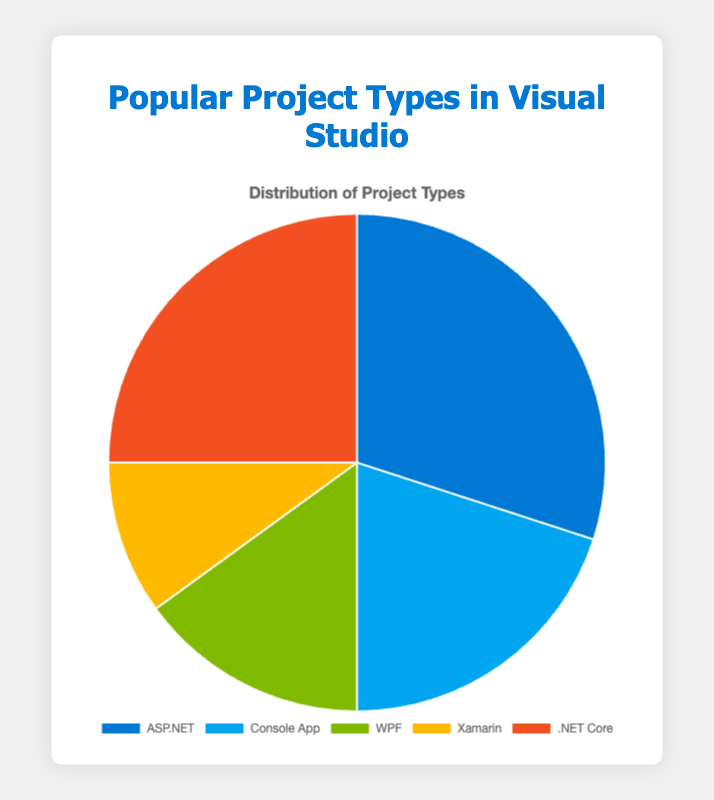What is the most popular project type in Visual Studio according to the pie chart? The pie chart shows that ASP.NET has the largest segment at 30%, which makes it the most popular project type in Visual Studio.
Answer: ASP.NET Which project type is less popular, Xamarin or WPF? From the pie chart, Xamarin has 10% while WPF has 15%. Since 10% is less than 15%, Xamarin is less popular than WPF.
Answer: Xamarin If you combine the percentages of Console App and .NET Core, what is their total percentage? The pie chart shows Console App at 20% and .NET Core at 25%. Adding them together: 20% + 25% equals 45%.
Answer: 45% Which project type has exactly half the percentage of the most popular project type? ASP.NET is the most popular at 30%. Half of 30% is 15%, which matches the percentage for WPF.
Answer: WPF What is the difference in popularity between the most and least popular project types? The most popular project type (ASP.NET) is at 30%, and the least popular (Xamarin) is at 10%. The difference is 30% - 10%, which is 20%.
Answer: 20% Which project types, if combined, would equal the popularity of ASP.NET? ASP.NET is at 30%. Adding the percentages of Console App (20%) and Xamarin (10%) sums to 20% + 10% = 30%, matching ASP.NET.
Answer: Console App and Xamarin What is the cumulative percentage of all project types except for the most popular one? Excluding ASP.NET (30%), add the percentages of Console App (20%), WPF (15%), Xamarin (10%), and .NET Core (25%): 20% + 15% + 10% + 25% = 70%.
Answer: 70% Which project types have a percentage difference of 5% between them? The chart shows WPF at 15% and Xamarin at 10%. The difference is 15% - 10% = 5%.
Answer: WPF and Xamarin If you add WPF and .NET Core percentages together, would they sum up to more than half of the total? WPF is 15% and .NET Core 25%. Adding them: 15% + 25% = 40%, which is less than 50%.
Answer: No 